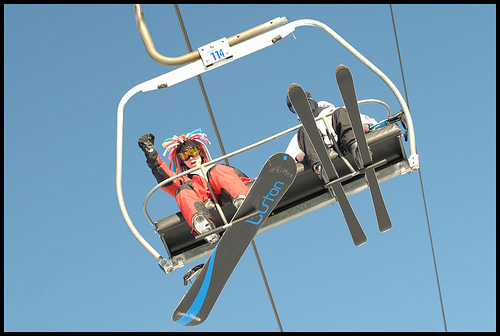Identify and read out the text in this image. 114 burton 